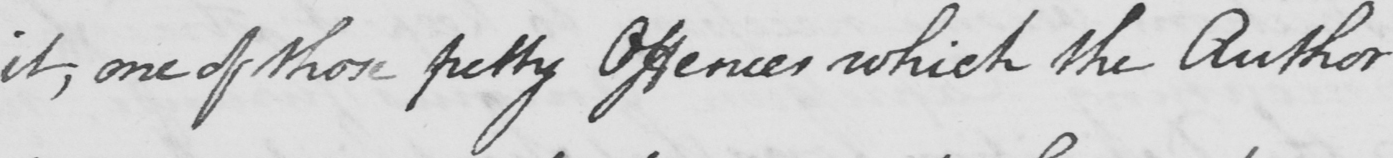What is written in this line of handwriting? it , one of those petty Offences which the Author 